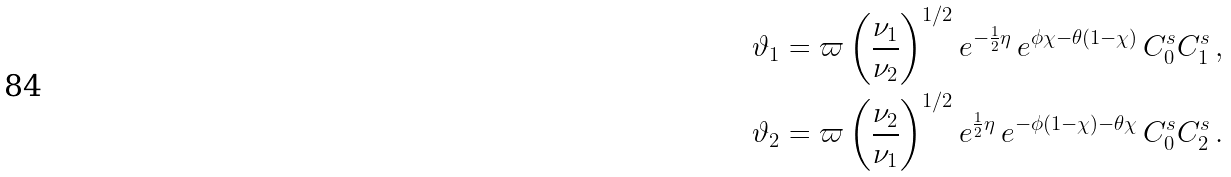<formula> <loc_0><loc_0><loc_500><loc_500>\vartheta _ { 1 } & = \varpi \left ( \frac { \nu _ { 1 } } { \nu _ { 2 } } \right ) ^ { 1 / 2 } e ^ { - \frac { 1 } { 2 } \eta } \, e ^ { \phi \chi - \theta ( 1 - \chi ) } \, C _ { 0 } ^ { s } C _ { 1 } ^ { s } \, , \\ \vartheta _ { 2 } & = \varpi \left ( \frac { \nu _ { 2 } } { \nu _ { 1 } } \right ) ^ { 1 / 2 } e ^ { \frac { 1 } { 2 } \eta } \, e ^ { - \phi ( 1 - \chi ) - \theta \chi } \, C _ { 0 } ^ { s } C _ { 2 } ^ { s } \, .</formula> 